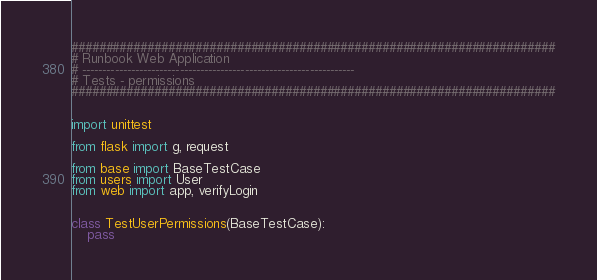Convert code to text. <code><loc_0><loc_0><loc_500><loc_500><_Python_>######################################################################
# Runbook Web Application
# -------------------------------------------------------------------
# Tests - permissions
######################################################################


import unittest

from flask import g, request

from base import BaseTestCase
from users import User
from web import app, verifyLogin


class TestUserPermissions(BaseTestCase):
    pass
</code> 